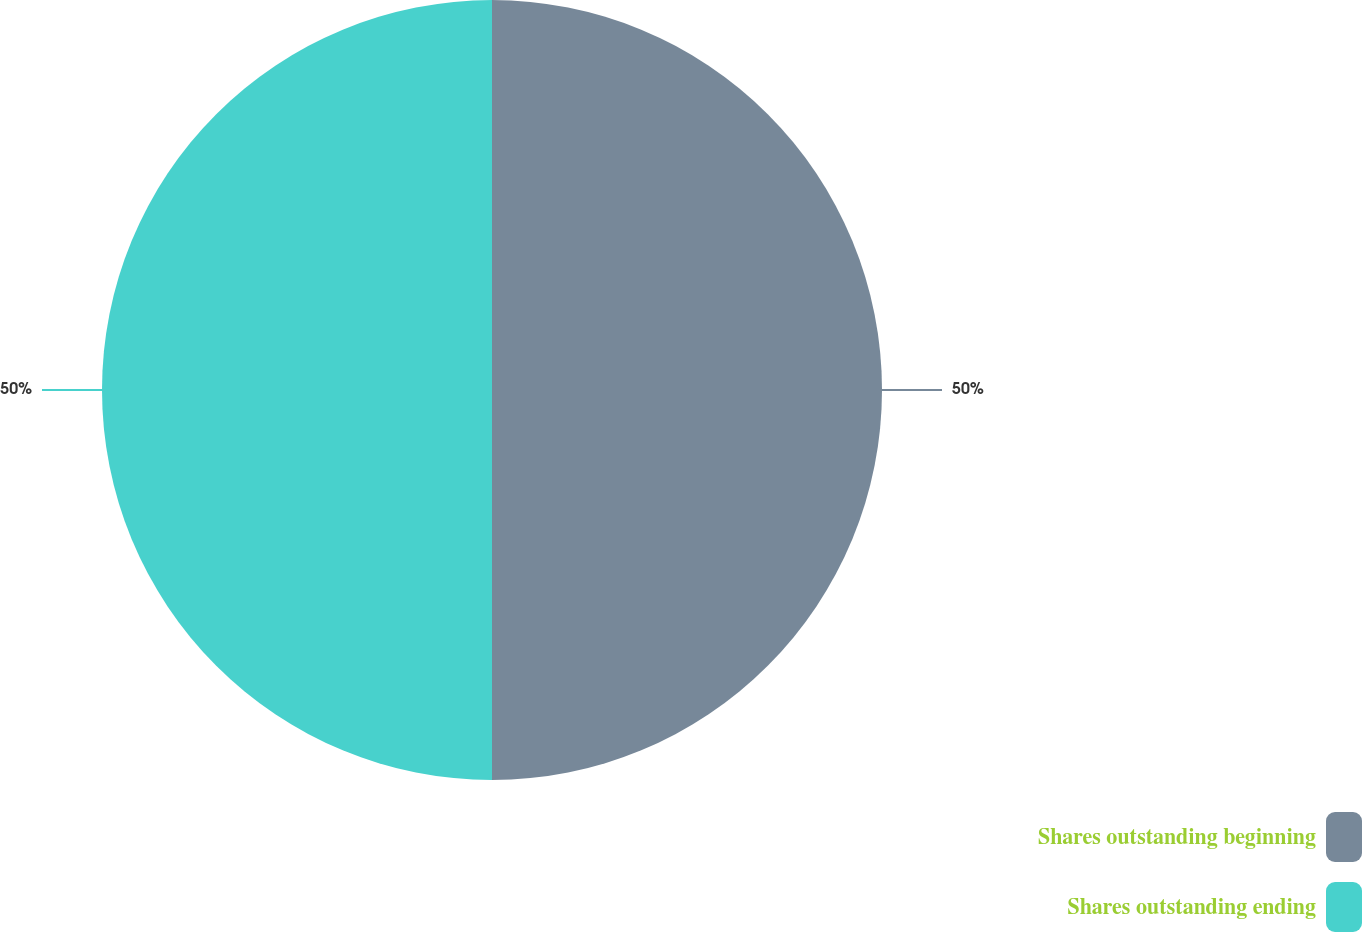<chart> <loc_0><loc_0><loc_500><loc_500><pie_chart><fcel>Shares outstanding beginning<fcel>Shares outstanding ending<nl><fcel>50.0%<fcel>50.0%<nl></chart> 